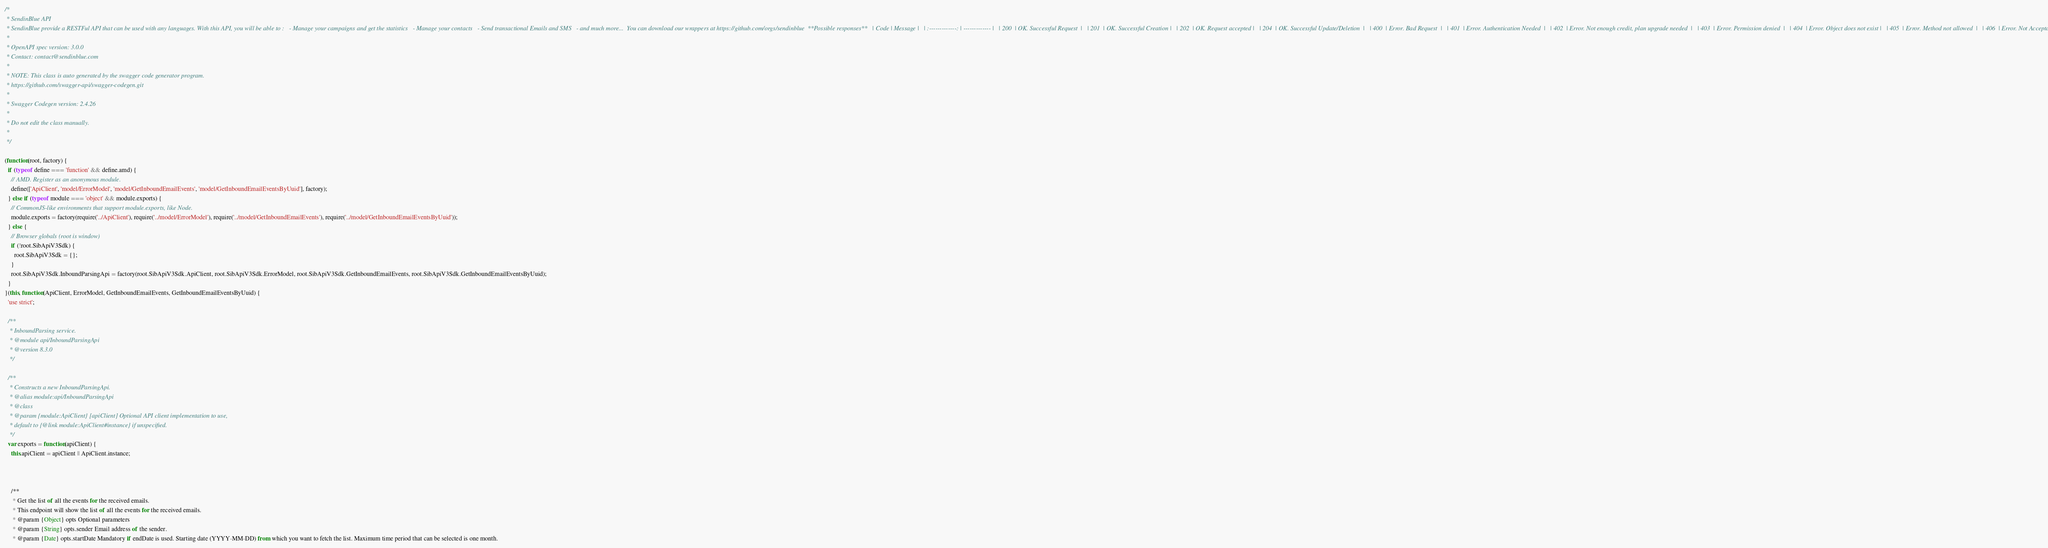<code> <loc_0><loc_0><loc_500><loc_500><_JavaScript_>/*
 * SendinBlue API
 * SendinBlue provide a RESTFul API that can be used with any languages. With this API, you will be able to :   - Manage your campaigns and get the statistics   - Manage your contacts   - Send transactional Emails and SMS   - and much more...  You can download our wrappers at https://github.com/orgs/sendinblue  **Possible responses**   | Code | Message |   | :-------------: | ------------- |   | 200  | OK. Successful Request  |   | 201  | OK. Successful Creation |   | 202  | OK. Request accepted |   | 204  | OK. Successful Update/Deletion  |   | 400  | Error. Bad Request  |   | 401  | Error. Authentication Needed  |   | 402  | Error. Not enough credit, plan upgrade needed  |   | 403  | Error. Permission denied  |   | 404  | Error. Object does not exist |   | 405  | Error. Method not allowed  |   | 406  | Error. Not Acceptable  | 
 *
 * OpenAPI spec version: 3.0.0
 * Contact: contact@sendinblue.com
 *
 * NOTE: This class is auto generated by the swagger code generator program.
 * https://github.com/swagger-api/swagger-codegen.git
 *
 * Swagger Codegen version: 2.4.26
 *
 * Do not edit the class manually.
 *
 */

(function(root, factory) {
  if (typeof define === 'function' && define.amd) {
    // AMD. Register as an anonymous module.
    define(['ApiClient', 'model/ErrorModel', 'model/GetInboundEmailEvents', 'model/GetInboundEmailEventsByUuid'], factory);
  } else if (typeof module === 'object' && module.exports) {
    // CommonJS-like environments that support module.exports, like Node.
    module.exports = factory(require('../ApiClient'), require('../model/ErrorModel'), require('../model/GetInboundEmailEvents'), require('../model/GetInboundEmailEventsByUuid'));
  } else {
    // Browser globals (root is window)
    if (!root.SibApiV3Sdk) {
      root.SibApiV3Sdk = {};
    }
    root.SibApiV3Sdk.InboundParsingApi = factory(root.SibApiV3Sdk.ApiClient, root.SibApiV3Sdk.ErrorModel, root.SibApiV3Sdk.GetInboundEmailEvents, root.SibApiV3Sdk.GetInboundEmailEventsByUuid);
  }
}(this, function(ApiClient, ErrorModel, GetInboundEmailEvents, GetInboundEmailEventsByUuid) {
  'use strict';

  /**
   * InboundParsing service.
   * @module api/InboundParsingApi
   * @version 8.3.0
   */

  /**
   * Constructs a new InboundParsingApi. 
   * @alias module:api/InboundParsingApi
   * @class
   * @param {module:ApiClient} [apiClient] Optional API client implementation to use,
   * default to {@link module:ApiClient#instance} if unspecified.
   */
  var exports = function(apiClient) {
    this.apiClient = apiClient || ApiClient.instance;



    /**
     * Get the list of all the events for the received emails.
     * This endpoint will show the list of all the events for the received emails.
     * @param {Object} opts Optional parameters
     * @param {String} opts.sender Email address of the sender.
     * @param {Date} opts.startDate Mandatory if endDate is used. Starting date (YYYY-MM-DD) from which you want to fetch the list. Maximum time period that can be selected is one month.</code> 